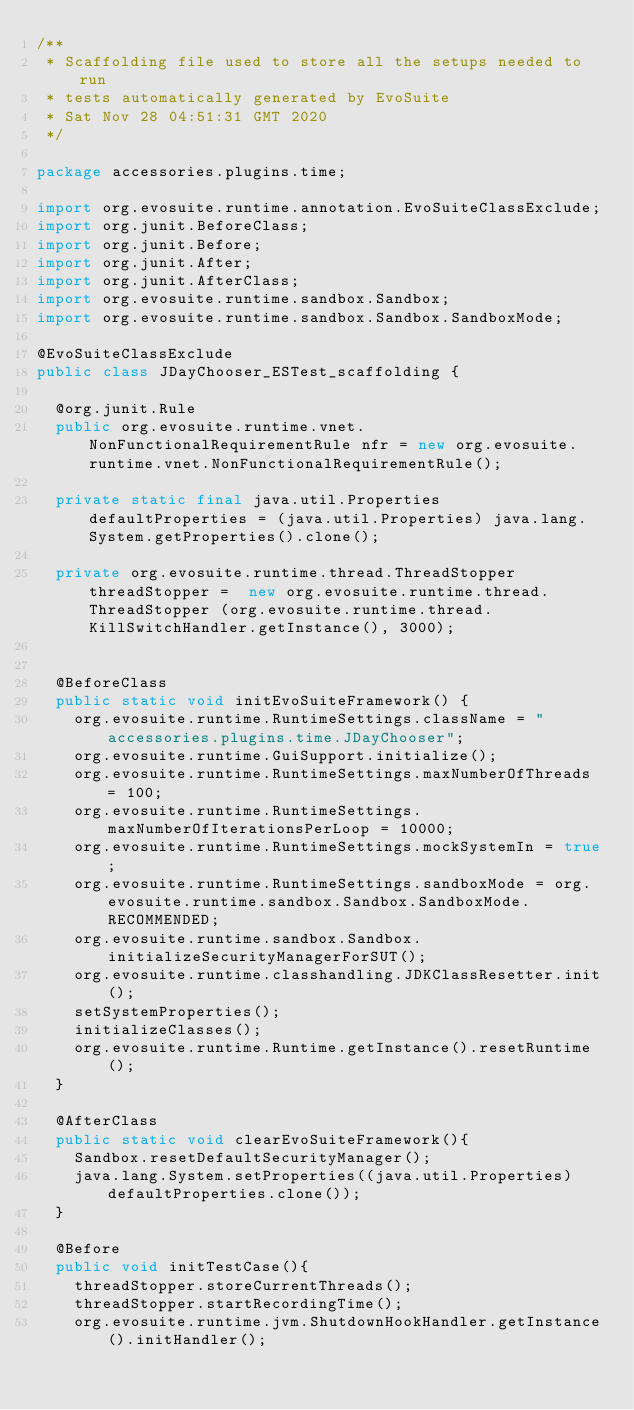Convert code to text. <code><loc_0><loc_0><loc_500><loc_500><_Java_>/**
 * Scaffolding file used to store all the setups needed to run 
 * tests automatically generated by EvoSuite
 * Sat Nov 28 04:51:31 GMT 2020
 */

package accessories.plugins.time;

import org.evosuite.runtime.annotation.EvoSuiteClassExclude;
import org.junit.BeforeClass;
import org.junit.Before;
import org.junit.After;
import org.junit.AfterClass;
import org.evosuite.runtime.sandbox.Sandbox;
import org.evosuite.runtime.sandbox.Sandbox.SandboxMode;

@EvoSuiteClassExclude
public class JDayChooser_ESTest_scaffolding {

  @org.junit.Rule 
  public org.evosuite.runtime.vnet.NonFunctionalRequirementRule nfr = new org.evosuite.runtime.vnet.NonFunctionalRequirementRule();

  private static final java.util.Properties defaultProperties = (java.util.Properties) java.lang.System.getProperties().clone(); 

  private org.evosuite.runtime.thread.ThreadStopper threadStopper =  new org.evosuite.runtime.thread.ThreadStopper (org.evosuite.runtime.thread.KillSwitchHandler.getInstance(), 3000);


  @BeforeClass 
  public static void initEvoSuiteFramework() { 
    org.evosuite.runtime.RuntimeSettings.className = "accessories.plugins.time.JDayChooser"; 
    org.evosuite.runtime.GuiSupport.initialize(); 
    org.evosuite.runtime.RuntimeSettings.maxNumberOfThreads = 100; 
    org.evosuite.runtime.RuntimeSettings.maxNumberOfIterationsPerLoop = 10000; 
    org.evosuite.runtime.RuntimeSettings.mockSystemIn = true; 
    org.evosuite.runtime.RuntimeSettings.sandboxMode = org.evosuite.runtime.sandbox.Sandbox.SandboxMode.RECOMMENDED; 
    org.evosuite.runtime.sandbox.Sandbox.initializeSecurityManagerForSUT(); 
    org.evosuite.runtime.classhandling.JDKClassResetter.init();
    setSystemProperties();
    initializeClasses();
    org.evosuite.runtime.Runtime.getInstance().resetRuntime(); 
  } 

  @AfterClass 
  public static void clearEvoSuiteFramework(){ 
    Sandbox.resetDefaultSecurityManager(); 
    java.lang.System.setProperties((java.util.Properties) defaultProperties.clone()); 
  } 

  @Before 
  public void initTestCase(){ 
    threadStopper.storeCurrentThreads();
    threadStopper.startRecordingTime();
    org.evosuite.runtime.jvm.ShutdownHookHandler.getInstance().initHandler(); </code> 